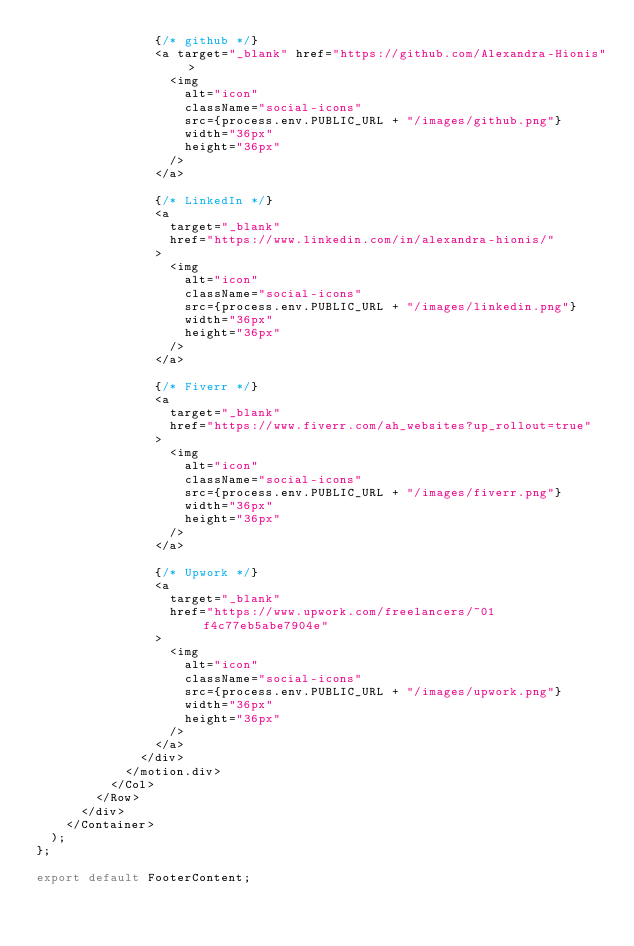<code> <loc_0><loc_0><loc_500><loc_500><_JavaScript_>                {/* github */}
                <a target="_blank" href="https://github.com/Alexandra-Hionis">
                  <img
                    alt="icon"
                    className="social-icons"
                    src={process.env.PUBLIC_URL + "/images/github.png"}
                    width="36px"
                    height="36px"
                  />
                </a>

                {/* LinkedIn */}
                <a
                  target="_blank"
                  href="https://www.linkedin.com/in/alexandra-hionis/"
                >
                  <img
                    alt="icon"
                    className="social-icons"
                    src={process.env.PUBLIC_URL + "/images/linkedin.png"}
                    width="36px"
                    height="36px"
                  />
                </a>

                {/* Fiverr */}
                <a
                  target="_blank"
                  href="https://www.fiverr.com/ah_websites?up_rollout=true"
                >
                  <img
                    alt="icon"
                    className="social-icons"
                    src={process.env.PUBLIC_URL + "/images/fiverr.png"}
                    width="36px"
                    height="36px"
                  />
                </a>

                {/* Upwork */}
                <a
                  target="_blank"
                  href="https://www.upwork.com/freelancers/~01f4c77eb5abe7904e"
                >
                  <img
                    alt="icon"
                    className="social-icons"
                    src={process.env.PUBLIC_URL + "/images/upwork.png"}
                    width="36px"
                    height="36px"
                  />
                </a>
              </div>
            </motion.div>
          </Col>
        </Row>
      </div>
    </Container>
  );
};

export default FooterContent;
</code> 